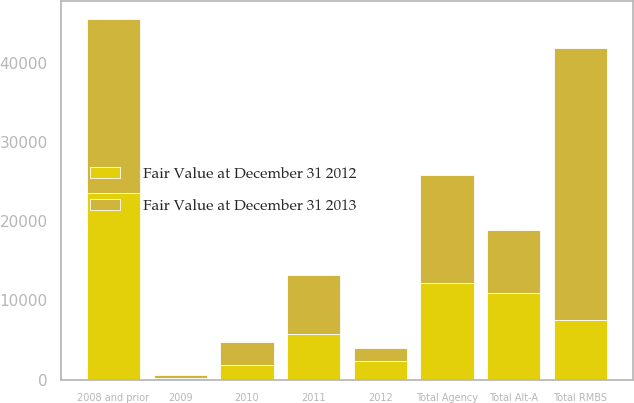Convert chart. <chart><loc_0><loc_0><loc_500><loc_500><stacked_bar_chart><ecel><fcel>2012<fcel>2011<fcel>2010<fcel>2009<fcel>2008 and prior<fcel>Total RMBS<fcel>Total Agency<fcel>Total Alt-A<nl><fcel>Fair Value at December 31 2012<fcel>2375<fcel>5736<fcel>1843<fcel>198<fcel>23625<fcel>7545<fcel>12216<fcel>10931<nl><fcel>Fair Value at December 31 2013<fcel>1630<fcel>7545<fcel>2951<fcel>378<fcel>21888<fcel>34392<fcel>13574<fcel>7924<nl></chart> 